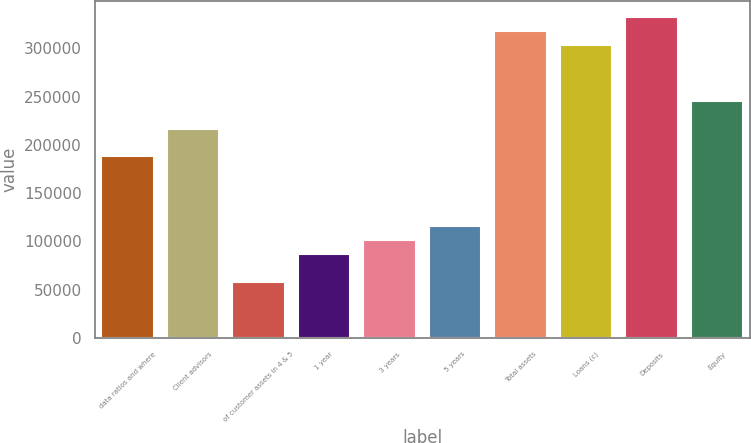<chart> <loc_0><loc_0><loc_500><loc_500><bar_chart><fcel>data ratios and where<fcel>Client advisors<fcel>of customer assets in 4 & 5<fcel>1 year<fcel>3 years<fcel>5 years<fcel>Total assets<fcel>Loans (c)<fcel>Deposits<fcel>Equity<nl><fcel>187953<fcel>216868<fcel>57831.7<fcel>86747.4<fcel>101205<fcel>115663<fcel>318074<fcel>303616<fcel>332532<fcel>245784<nl></chart> 